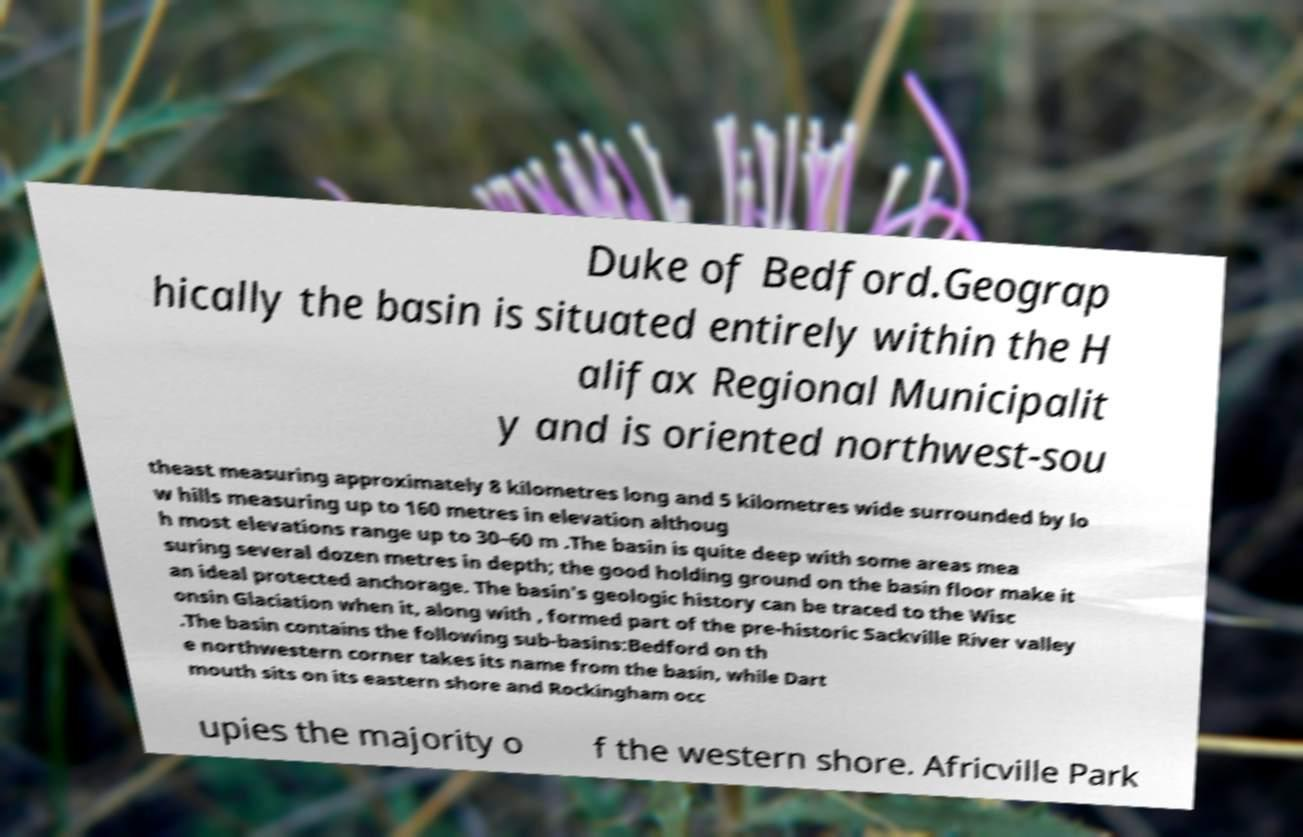There's text embedded in this image that I need extracted. Can you transcribe it verbatim? Duke of Bedford.Geograp hically the basin is situated entirely within the H alifax Regional Municipalit y and is oriented northwest-sou theast measuring approximately 8 kilometres long and 5 kilometres wide surrounded by lo w hills measuring up to 160 metres in elevation althoug h most elevations range up to 30–60 m .The basin is quite deep with some areas mea suring several dozen metres in depth; the good holding ground on the basin floor make it an ideal protected anchorage. The basin's geologic history can be traced to the Wisc onsin Glaciation when it, along with , formed part of the pre-historic Sackville River valley .The basin contains the following sub-basins:Bedford on th e northwestern corner takes its name from the basin, while Dart mouth sits on its eastern shore and Rockingham occ upies the majority o f the western shore. Africville Park 